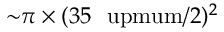<formula> <loc_0><loc_0><loc_500><loc_500>{ \sim } \pi \times ( 3 5 \ u p m u m / 2 ) ^ { 2 }</formula> 